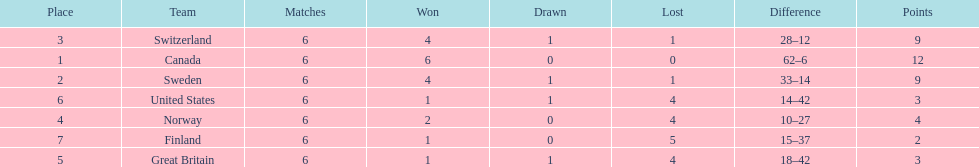What team placed next after sweden? Switzerland. 